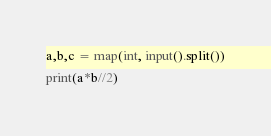Convert code to text. <code><loc_0><loc_0><loc_500><loc_500><_Python_>a,b,c = map(int, input().split())
print(a*b//2)</code> 